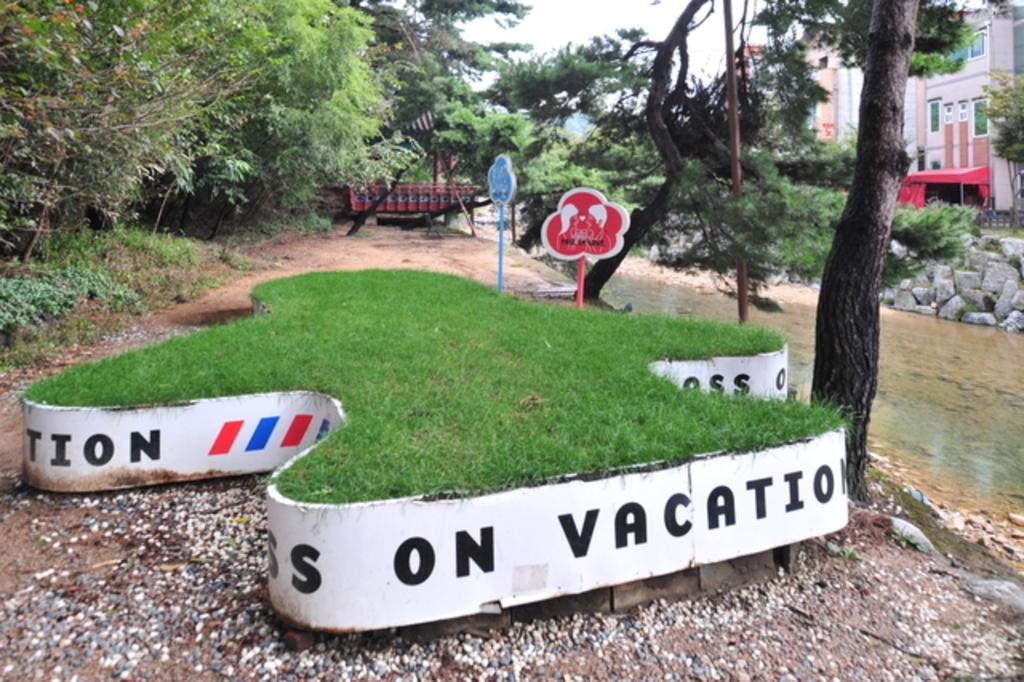What type of natural vegetation can be seen in the image? There are trees in the image. What type of man-made structures are present in the image? There are buildings in the image. What body of water is visible in the image? There is water visible in the image. What type of terrain is present in the image? There are rocks in the image. What type of signage is present in the image? There are boards with text in the image. What type of ground cover is present in the image? There is grass in the image. What is the weather like in the image? The sky is cloudy in the image. How does the kitty navigate the voyage in the image? There is no kitty present in the image, so it cannot navigate any voyage. What type of brake system is installed on the trees in the image? There are no brake systems present on the trees in the image; they are natural vegetation. 